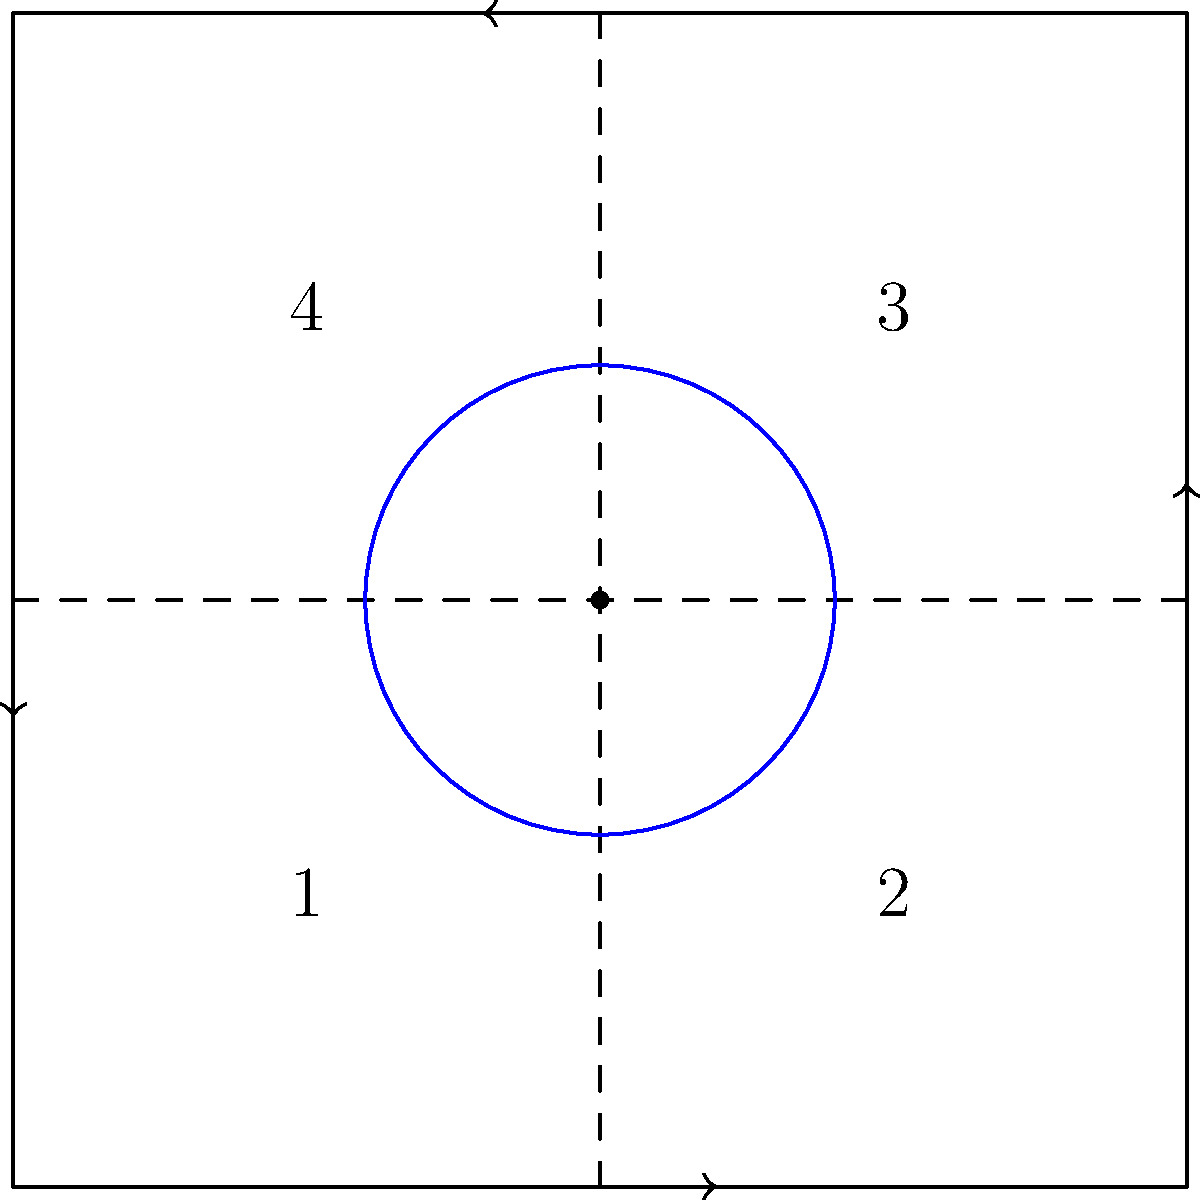In the bird's-eye view of an intersection shown above, which numbered quadrant should a vehicle be positioned in when making a left turn? To understand the correct positioning for a left turn, let's break it down step-by-step:

1. Identify the direction of travel: The arrows indicate that traffic moves counter-clockwise around the central circle.

2. Understand left turn positioning: When making a left turn, a vehicle should be in the leftmost lane of the approach to the intersection.

3. Analyze the quadrants:
   - Quadrant 1 is the left side when approaching from the bottom
   - Quadrant 2 is the right side when approaching from the bottom
   - Quadrant 3 is the right side when approaching from the left
   - Quadrant 4 is the left side when approaching from the left

4. Apply the left turn rule: For a left turn, the vehicle should be in the leftmost lane, which corresponds to the quadrant on the left side of the approach.

5. Identify the correct quadrant: Based on the traffic flow and left turn positioning, the correct quadrant for a left turn is either Quadrant 1 (when approaching from the bottom) or Quadrant 4 (when approaching from the left).

6. Choose the best answer: Since the question asks for a single quadrant, and Quadrant 1 is typically considered the primary left turn position in most driving scenarios, it is the most appropriate answer.
Answer: Quadrant 1 